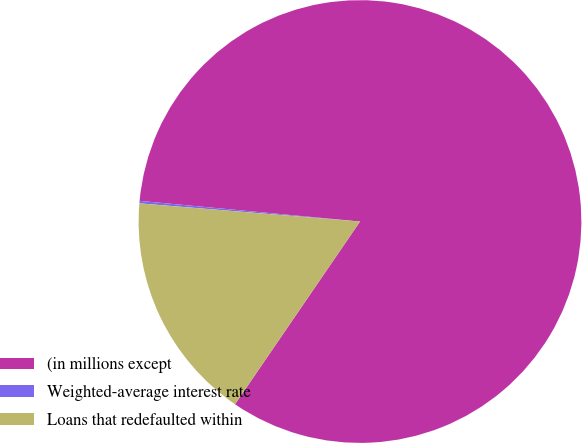Convert chart. <chart><loc_0><loc_0><loc_500><loc_500><pie_chart><fcel>(in millions except<fcel>Weighted-average interest rate<fcel>Loans that redefaulted within<nl><fcel>83.06%<fcel>0.18%<fcel>16.76%<nl></chart> 